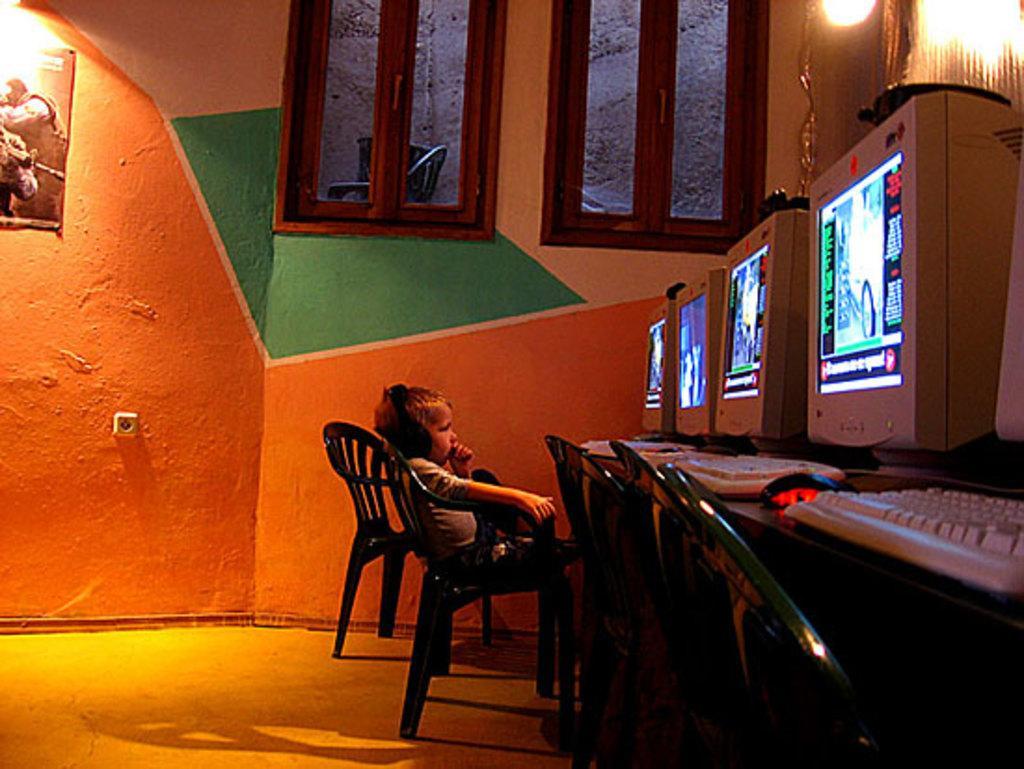In one or two sentences, can you explain what this image depicts? There is a kid sitting on chair and wired headset. We can see monitors,keyboards and mouse on table and chairs. We can see poster on wall,lights and floor. 